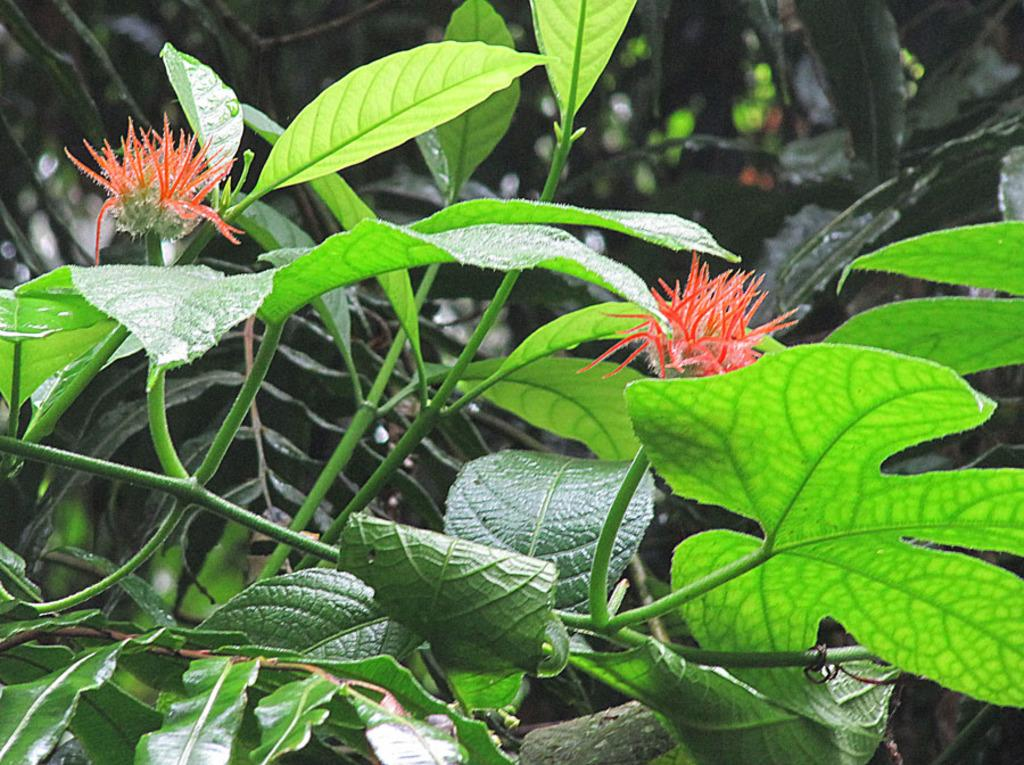What is present in the image? There is a plant in the image. What specific feature of the plant can be observed? The plant has flowers. Can you describe the background of the image? The backdrop of the image is blurred. How many eyes can be seen on the plant in the image? There are no eyes present on the plant in the image, as plants do not have eyes. What type of blade is being used to crush the flowers in the image? There is no blade or crushing action depicted in the image; the plant has flowers, but they are not being crushed. 